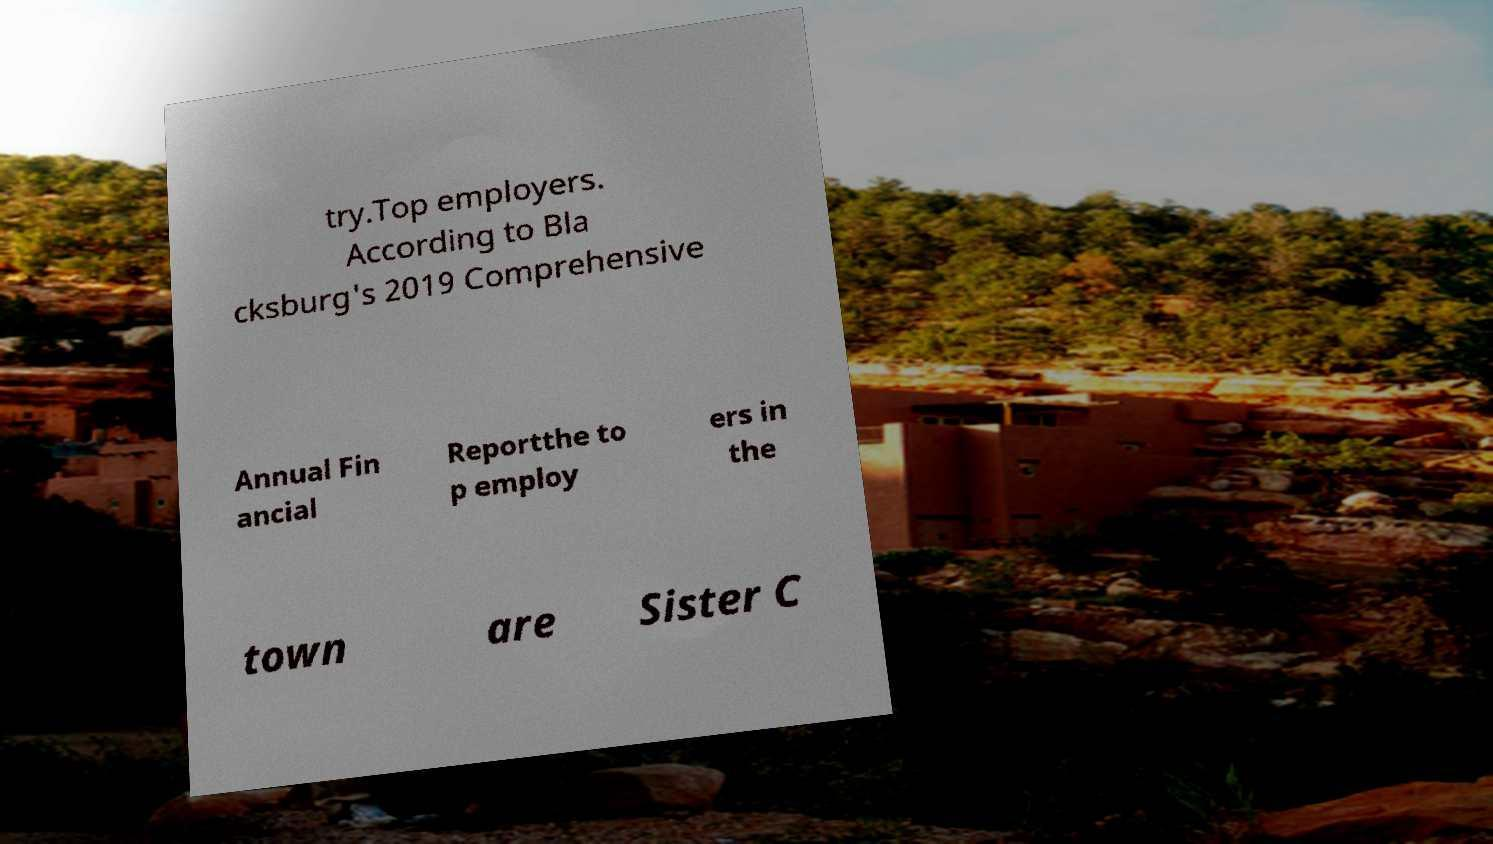I need the written content from this picture converted into text. Can you do that? try.Top employers. According to Bla cksburg's 2019 Comprehensive Annual Fin ancial Reportthe to p employ ers in the town are Sister C 